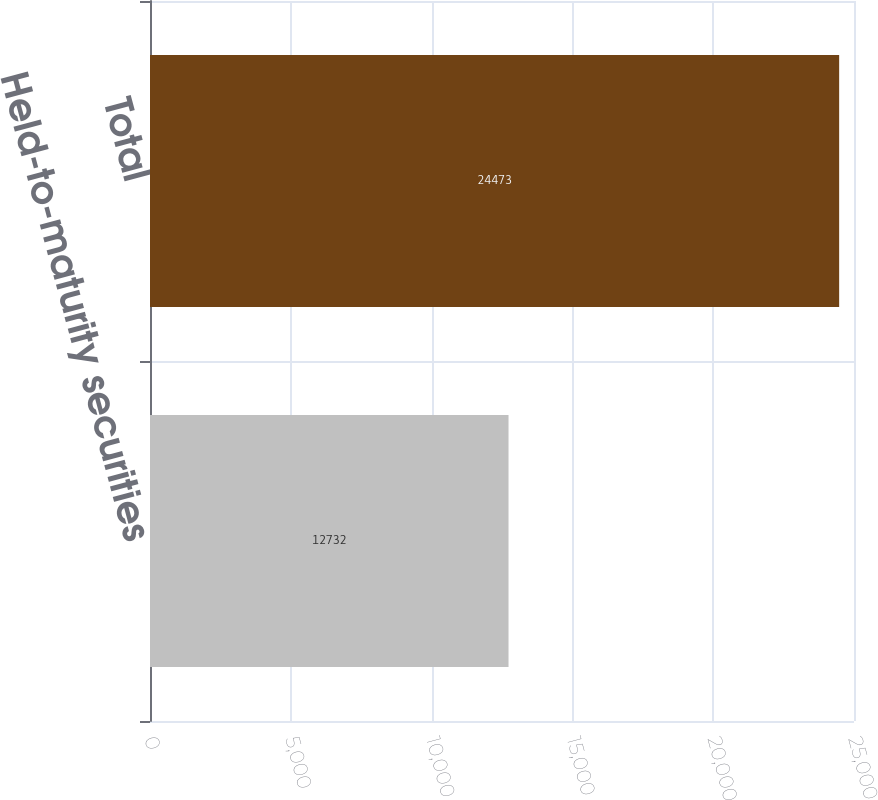Convert chart. <chart><loc_0><loc_0><loc_500><loc_500><bar_chart><fcel>Held-to-maturity securities<fcel>Total<nl><fcel>12732<fcel>24473<nl></chart> 